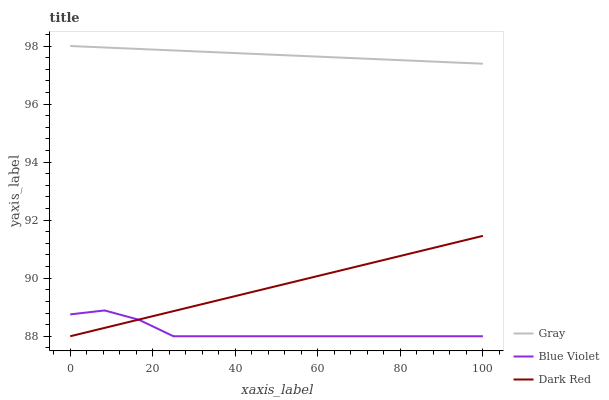Does Blue Violet have the minimum area under the curve?
Answer yes or no. Yes. Does Gray have the maximum area under the curve?
Answer yes or no. Yes. Does Dark Red have the minimum area under the curve?
Answer yes or no. No. Does Dark Red have the maximum area under the curve?
Answer yes or no. No. Is Gray the smoothest?
Answer yes or no. Yes. Is Blue Violet the roughest?
Answer yes or no. Yes. Is Dark Red the smoothest?
Answer yes or no. No. Is Dark Red the roughest?
Answer yes or no. No. Does Blue Violet have the lowest value?
Answer yes or no. Yes. Does Gray have the highest value?
Answer yes or no. Yes. Does Dark Red have the highest value?
Answer yes or no. No. Is Blue Violet less than Gray?
Answer yes or no. Yes. Is Gray greater than Blue Violet?
Answer yes or no. Yes. Does Dark Red intersect Blue Violet?
Answer yes or no. Yes. Is Dark Red less than Blue Violet?
Answer yes or no. No. Is Dark Red greater than Blue Violet?
Answer yes or no. No. Does Blue Violet intersect Gray?
Answer yes or no. No. 